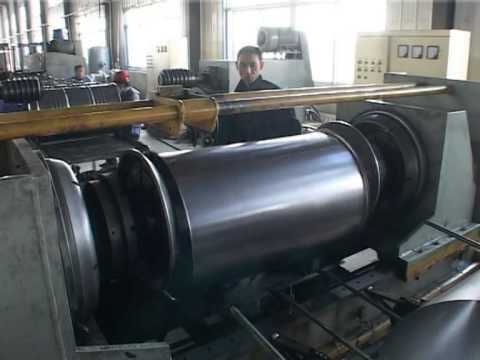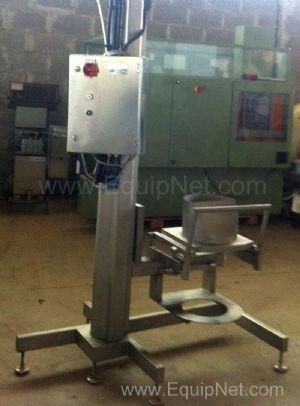The first image is the image on the left, the second image is the image on the right. Given the left and right images, does the statement "The left and right image contains the same amount of round metal barrels." hold true? Answer yes or no. No. 